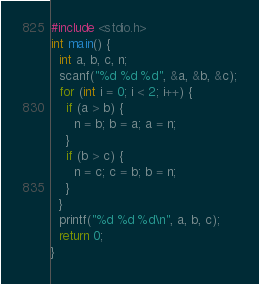Convert code to text. <code><loc_0><loc_0><loc_500><loc_500><_C_>#include <stdio.h>
int main() {
  int a, b, c, n;
  scanf("%d %d %d", &a, &b, &c);
  for (int i = 0; i < 2; i++) {
    if (a > b) {
      n = b; b = a; a = n;
    }
    if (b > c) {
      n = c; c = b; b = n;
    }
  }
  printf("%d %d %d\n", a, b, c);
  return 0;
}</code> 